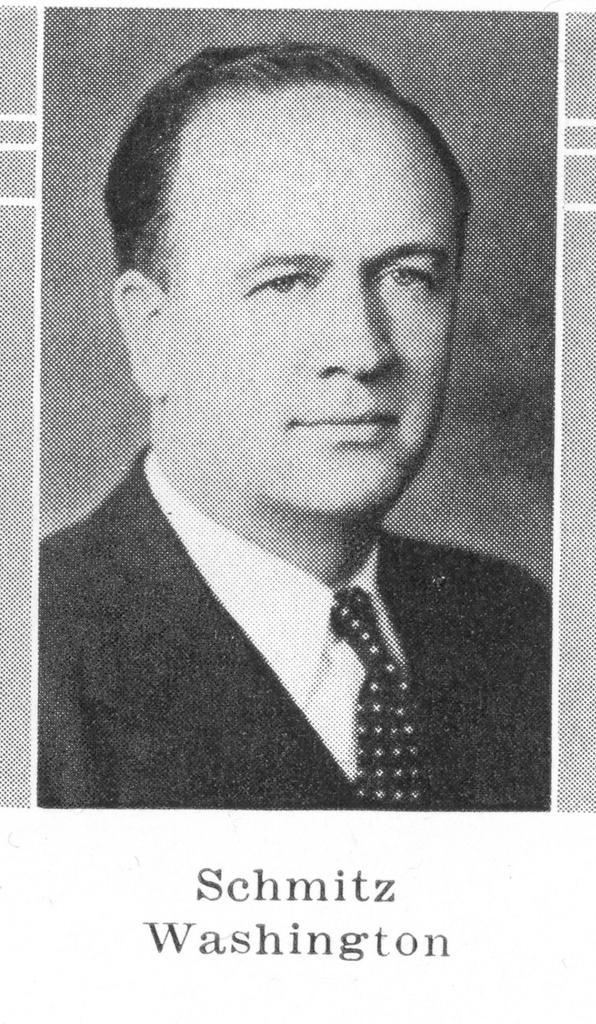In one or two sentences, can you explain what this image depicts? This is a picture of a guy whose name is Schwitz Washington. 